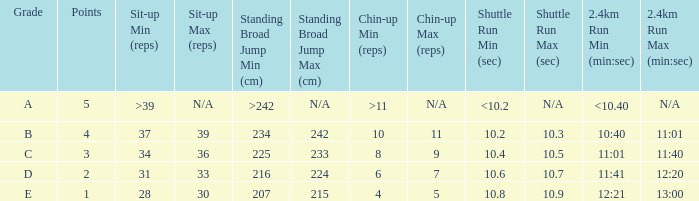Tell me the 2.4km run for points less than 2 12:21 - 13:00. 